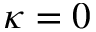Convert formula to latex. <formula><loc_0><loc_0><loc_500><loc_500>\kappa = 0</formula> 